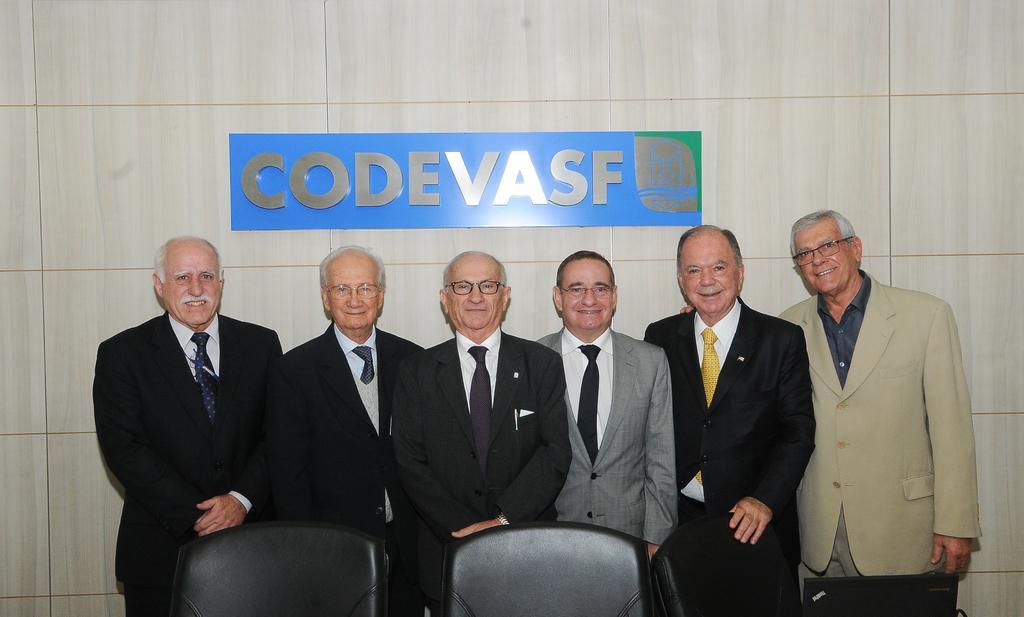Please provide a concise description of this image. There are persons in suits, smiling and standing. Beside them, there are two chairs arranged and a laptop. In the background, there is a hoarding attached to the wall. 